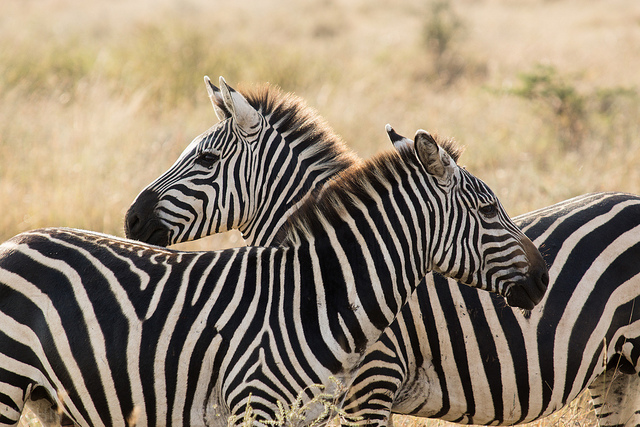Are these zebras facing the sharegpt4v/same direction? No, the zebras are facing opposite directions. 